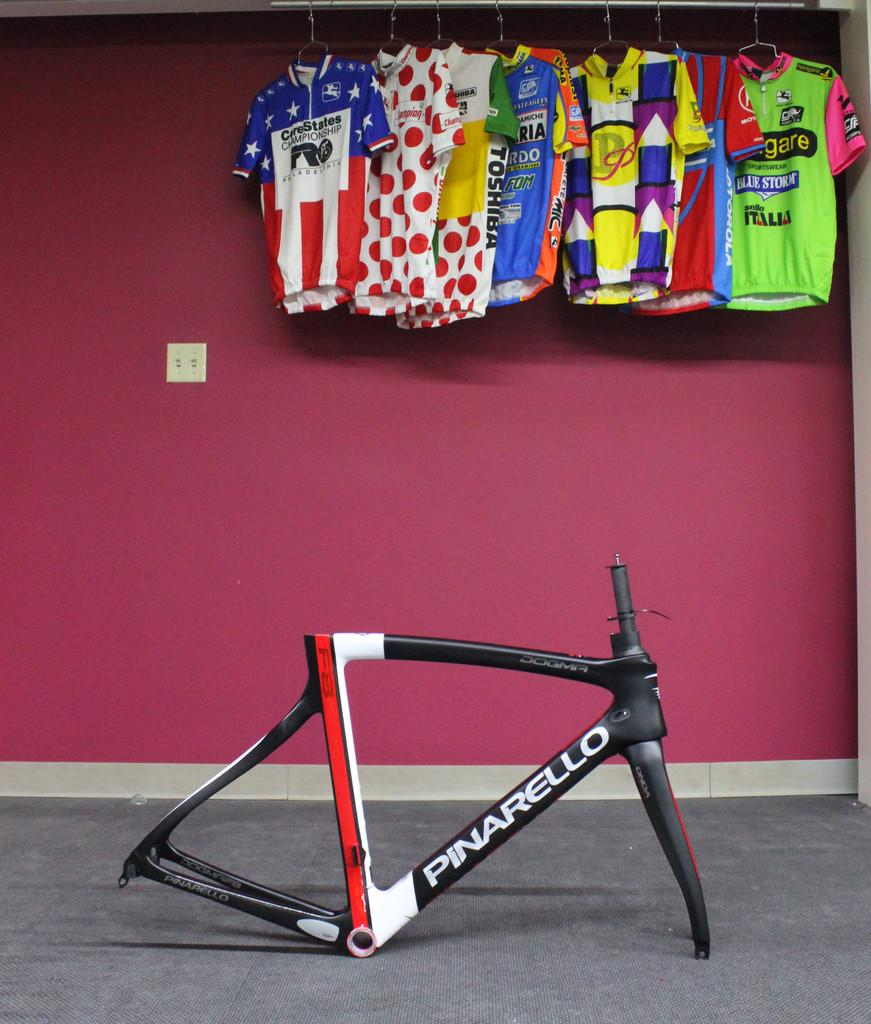<image>
Give a short and clear explanation of the subsequent image. A Pinarello bike part sitting in front of a wall with hanging sports jerseys. 